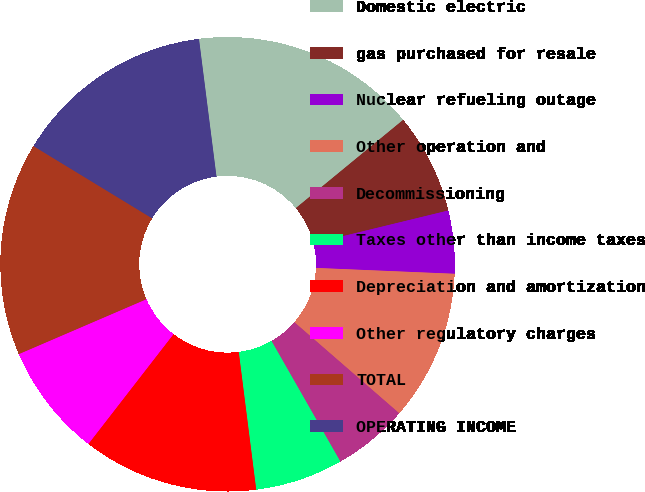Convert chart. <chart><loc_0><loc_0><loc_500><loc_500><pie_chart><fcel>Domestic electric<fcel>gas purchased for resale<fcel>Nuclear refueling outage<fcel>Other operation and<fcel>Decommissioning<fcel>Taxes other than income taxes<fcel>Depreciation and amortization<fcel>Other regulatory charges<fcel>TOTAL<fcel>OPERATING INCOME<nl><fcel>16.06%<fcel>7.15%<fcel>4.47%<fcel>10.71%<fcel>5.36%<fcel>6.25%<fcel>12.5%<fcel>8.04%<fcel>15.17%<fcel>14.28%<nl></chart> 